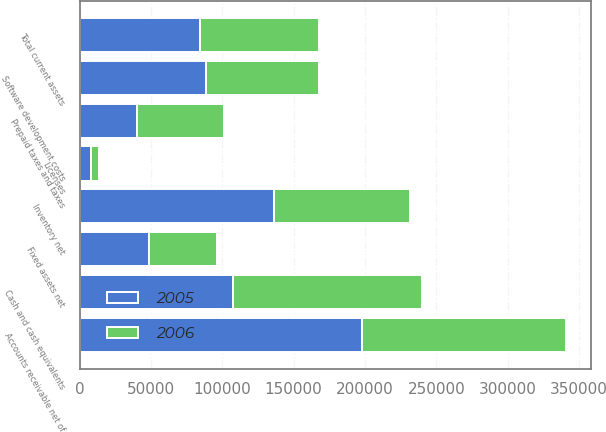Convert chart to OTSL. <chart><loc_0><loc_0><loc_500><loc_500><stacked_bar_chart><ecel><fcel>Cash and cash equivalents<fcel>Accounts receivable net of<fcel>Inventory net<fcel>Software development costs<fcel>Licenses<fcel>Prepaid taxes and taxes<fcel>Total current assets<fcel>Fixed assets net<nl><fcel>2006<fcel>132480<fcel>143199<fcel>95520<fcel>79248<fcel>5959<fcel>60407<fcel>84037<fcel>47496<nl><fcel>2005<fcel>107195<fcel>197861<fcel>136227<fcel>88826<fcel>7651<fcel>40453<fcel>84037<fcel>48617<nl></chart> 